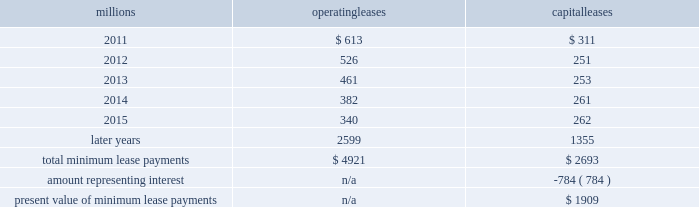2010 .
On november 1 , 2010 , we redeemed all $ 400 million of our outstanding 6.65% ( 6.65 % ) notes due january 15 , 2011 .
The redemption resulted in a $ 5 million early extinguishment charge .
Receivables securitization facility 2013 at december 31 , 2010 , we have recorded $ 100 million as secured debt under our receivables securitization facility .
( see further discussion of our receivables securitization facility in note 10. ) 15 .
Variable interest entities we have entered into various lease transactions in which the structure of the leases contain variable interest entities ( vies ) .
These vies were created solely for the purpose of doing lease transactions ( principally involving railroad equipment and facilities ) and have no other activities , assets or liabilities outside of the lease transactions .
Within these lease arrangements , we have the right to purchase some or all of the assets at fixed prices .
Depending on market conditions , fixed-price purchase options available in the leases could potentially provide benefits to us ; however , these benefits are not expected to be significant .
We maintain and operate the assets based on contractual obligations within the lease arrangements , which set specific guidelines consistent within the railroad industry .
As such , we have no control over activities that could materially impact the fair value of the leased assets .
We do not hold the power to direct the activities of the vies and , therefore , do not control the ongoing activities that have a significant impact on the economic performance of the vies .
Additionally , we do not have the obligation to absorb losses of the vies or the right to receive benefits of the vies that could potentially be significant to the we are not considered to be the primary beneficiary and do not consolidate these vies because our actions and decisions do not have the most significant effect on the vie 2019s performance and our fixed-price purchase price options are not considered to be potentially significant to the vie 2019s .
The future minimum lease payments associated with the vie leases totaled $ 4.2 billion as of december 31 , 2010 .
16 .
Leases we lease certain locomotives , freight cars , and other property .
The consolidated statement of financial position as of december 31 , 2010 and 2009 included $ 2520 million , net of $ 901 million of accumulated depreciation , and $ 2754 million , net of $ 927 million of accumulated depreciation , respectively , for properties held under capital leases .
A charge to income resulting from the depreciation for assets held under capital leases is included within depreciation expense in our consolidated statements of income .
Future minimum lease payments for operating and capital leases with initial or remaining non-cancelable lease terms in excess of one year as of december 31 , 2010 , were as follows : millions operating leases capital leases .
The majority of capital lease payments relate to locomotives .
Rent expense for operating leases with terms exceeding one month was $ 624 million in 2010 , $ 686 million in 2009 , and $ 747 million in 2008 .
When cash rental payments are not made on a straight-line basis , we recognize variable rental expense on a straight-line basis over the lease term .
Contingent rentals and sub-rentals are not significant. .
How much less , in percentage , were the capital leases in 2011 than the operating leases? 
Computations: ((613 - 311) / 613)
Answer: 0.49266. 2010 .
On november 1 , 2010 , we redeemed all $ 400 million of our outstanding 6.65% ( 6.65 % ) notes due january 15 , 2011 .
The redemption resulted in a $ 5 million early extinguishment charge .
Receivables securitization facility 2013 at december 31 , 2010 , we have recorded $ 100 million as secured debt under our receivables securitization facility .
( see further discussion of our receivables securitization facility in note 10. ) 15 .
Variable interest entities we have entered into various lease transactions in which the structure of the leases contain variable interest entities ( vies ) .
These vies were created solely for the purpose of doing lease transactions ( principally involving railroad equipment and facilities ) and have no other activities , assets or liabilities outside of the lease transactions .
Within these lease arrangements , we have the right to purchase some or all of the assets at fixed prices .
Depending on market conditions , fixed-price purchase options available in the leases could potentially provide benefits to us ; however , these benefits are not expected to be significant .
We maintain and operate the assets based on contractual obligations within the lease arrangements , which set specific guidelines consistent within the railroad industry .
As such , we have no control over activities that could materially impact the fair value of the leased assets .
We do not hold the power to direct the activities of the vies and , therefore , do not control the ongoing activities that have a significant impact on the economic performance of the vies .
Additionally , we do not have the obligation to absorb losses of the vies or the right to receive benefits of the vies that could potentially be significant to the we are not considered to be the primary beneficiary and do not consolidate these vies because our actions and decisions do not have the most significant effect on the vie 2019s performance and our fixed-price purchase price options are not considered to be potentially significant to the vie 2019s .
The future minimum lease payments associated with the vie leases totaled $ 4.2 billion as of december 31 , 2010 .
16 .
Leases we lease certain locomotives , freight cars , and other property .
The consolidated statement of financial position as of december 31 , 2010 and 2009 included $ 2520 million , net of $ 901 million of accumulated depreciation , and $ 2754 million , net of $ 927 million of accumulated depreciation , respectively , for properties held under capital leases .
A charge to income resulting from the depreciation for assets held under capital leases is included within depreciation expense in our consolidated statements of income .
Future minimum lease payments for operating and capital leases with initial or remaining non-cancelable lease terms in excess of one year as of december 31 , 2010 , were as follows : millions operating leases capital leases .
The majority of capital lease payments relate to locomotives .
Rent expense for operating leases with terms exceeding one month was $ 624 million in 2010 , $ 686 million in 2009 , and $ 747 million in 2008 .
When cash rental payments are not made on a straight-line basis , we recognize variable rental expense on a straight-line basis over the lease term .
Contingent rentals and sub-rentals are not significant. .
What is the average rent expense for operating leases with terms exceeding one month from 2008-2010 , in millions? 
Computations: (((624 + 686) + 747) / 3)
Answer: 685.66667. 